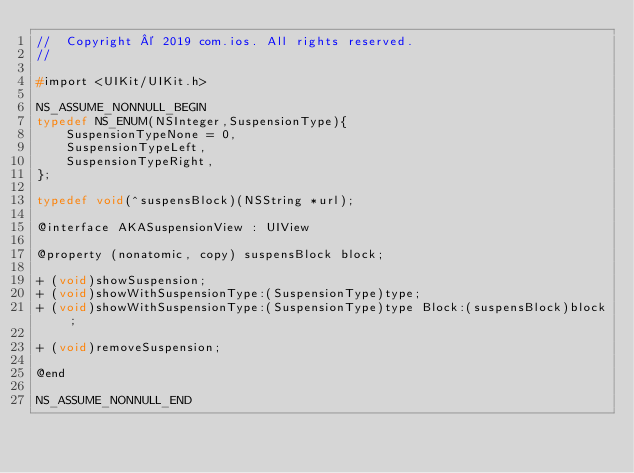<code> <loc_0><loc_0><loc_500><loc_500><_C_>//  Copyright © 2019 com.ios. All rights reserved.
//

#import <UIKit/UIKit.h>

NS_ASSUME_NONNULL_BEGIN
typedef NS_ENUM(NSInteger,SuspensionType){
    SuspensionTypeNone = 0,
    SuspensionTypeLeft,
    SuspensionTypeRight,
};

typedef void(^suspensBlock)(NSString *url);

@interface AKASuspensionView : UIView

@property (nonatomic, copy) suspensBlock block;

+ (void)showSuspension;
+ (void)showWithSuspensionType:(SuspensionType)type;
+ (void)showWithSuspensionType:(SuspensionType)type Block:(suspensBlock)block;

+ (void)removeSuspension;

@end

NS_ASSUME_NONNULL_END
</code> 